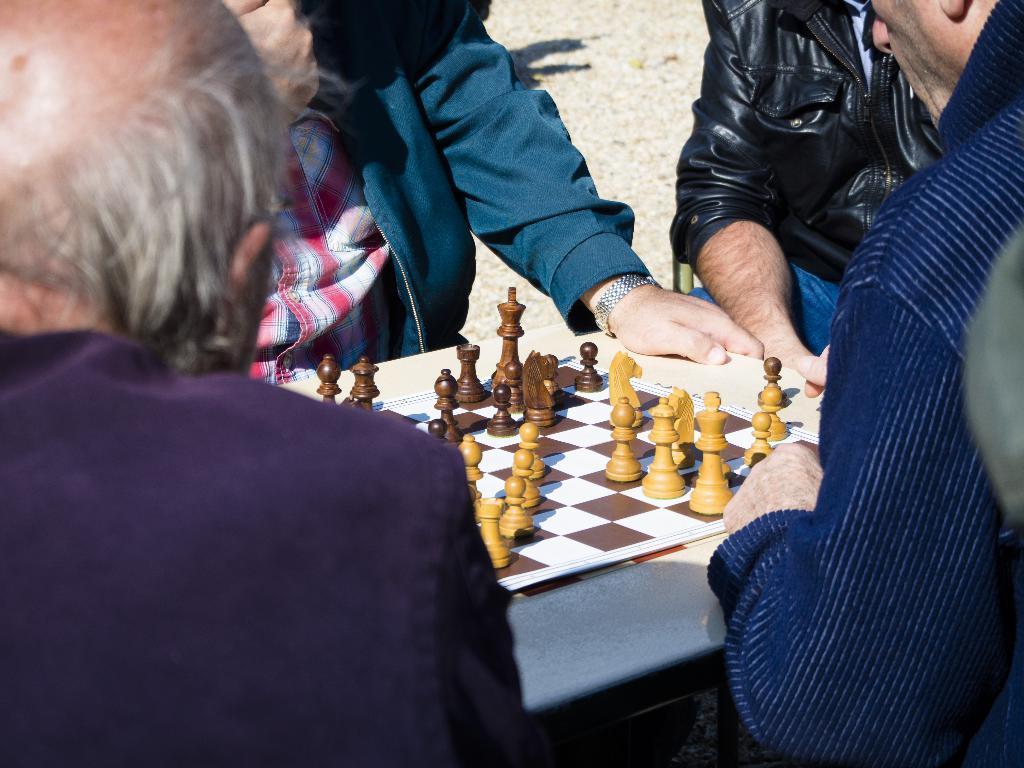Can you describe this image briefly? In this image there are group of people playing chess. 